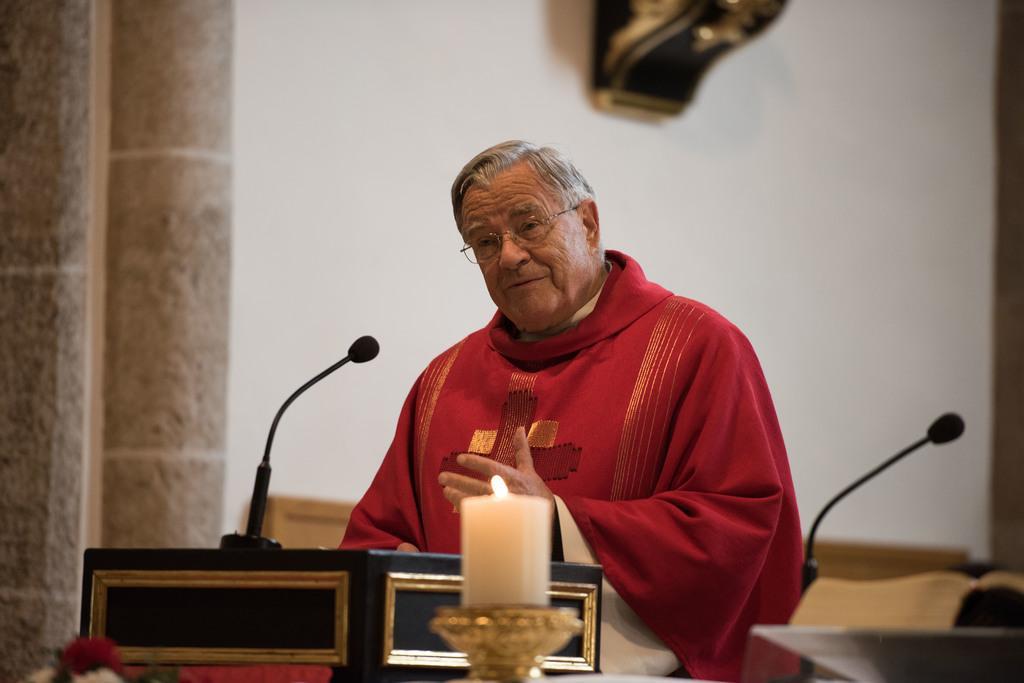How would you summarize this image in a sentence or two? In the middle of the image, there is a person in red color coat. In front of him, there is a mic on stand and there is a candle. Beside him, there is another mic. In the background, there is white wall. 